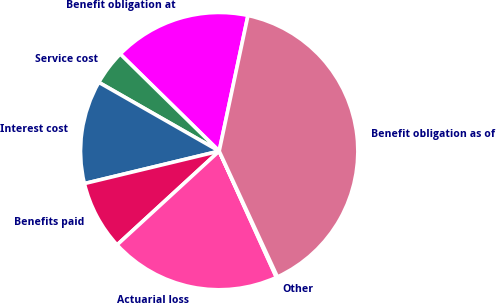Convert chart. <chart><loc_0><loc_0><loc_500><loc_500><pie_chart><fcel>Benefit obligation at<fcel>Service cost<fcel>Interest cost<fcel>Benefits paid<fcel>Actuarial loss<fcel>Other<fcel>Benefit obligation as of<nl><fcel>15.98%<fcel>4.09%<fcel>12.02%<fcel>8.06%<fcel>19.95%<fcel>0.13%<fcel>39.77%<nl></chart> 